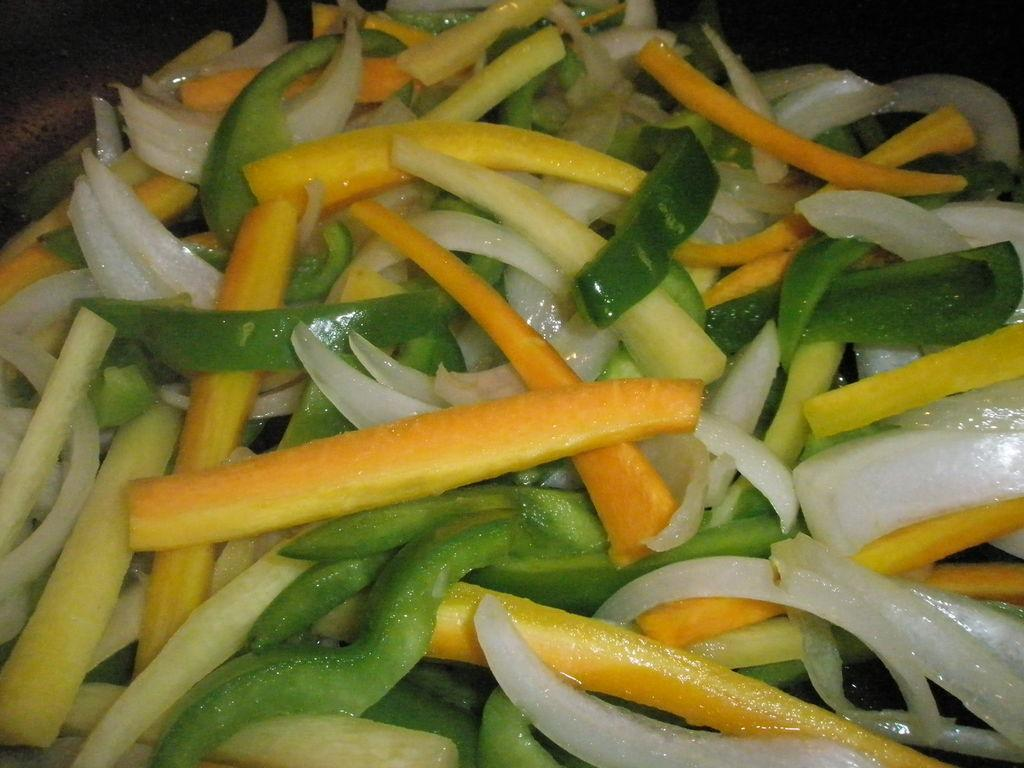What type of food can be seen in the image? There are cut pieces of vegetables in the image. Can you describe the variety of vegetables in the image? The vegetables are of different types. What error can be seen in the image? There is no error present in the image; it simply shows cut pieces of vegetables of different types. 